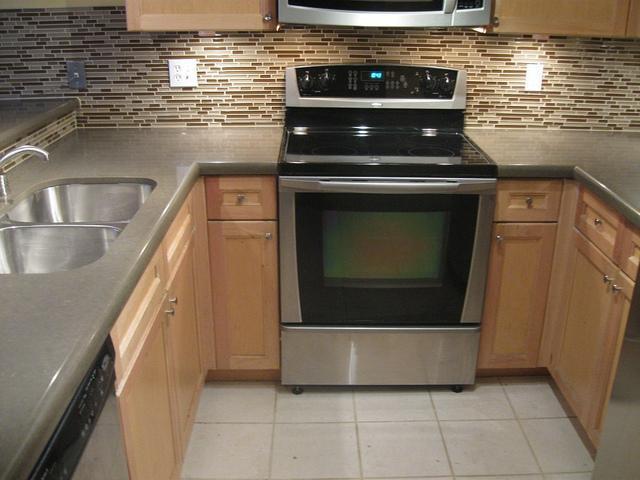What is the innermost color reflected off the center of the oven?
Make your selection and explain in format: 'Answer: answer
Rationale: rationale.'
Options: Yellow, blue, green, red. Answer: red.
Rationale: The center of the reflection area is red. 